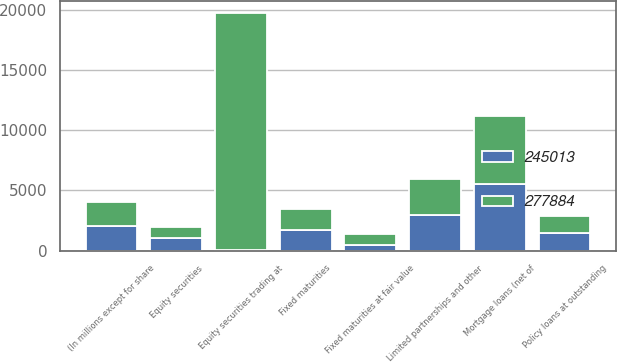<chart> <loc_0><loc_0><loc_500><loc_500><stacked_bar_chart><ecel><fcel>(In millions except for share<fcel>Fixed maturities<fcel>Fixed maturities at fair value<fcel>Equity securities trading at<fcel>Equity securities<fcel>Mortgage loans (net of<fcel>Policy loans at outstanding<fcel>Limited partnerships and other<nl><fcel>245013<fcel>2014<fcel>1722<fcel>488<fcel>11<fcel>1047<fcel>5556<fcel>1431<fcel>2942<nl><fcel>277884<fcel>2013<fcel>1722<fcel>844<fcel>19745<fcel>868<fcel>5598<fcel>1420<fcel>3040<nl></chart> 